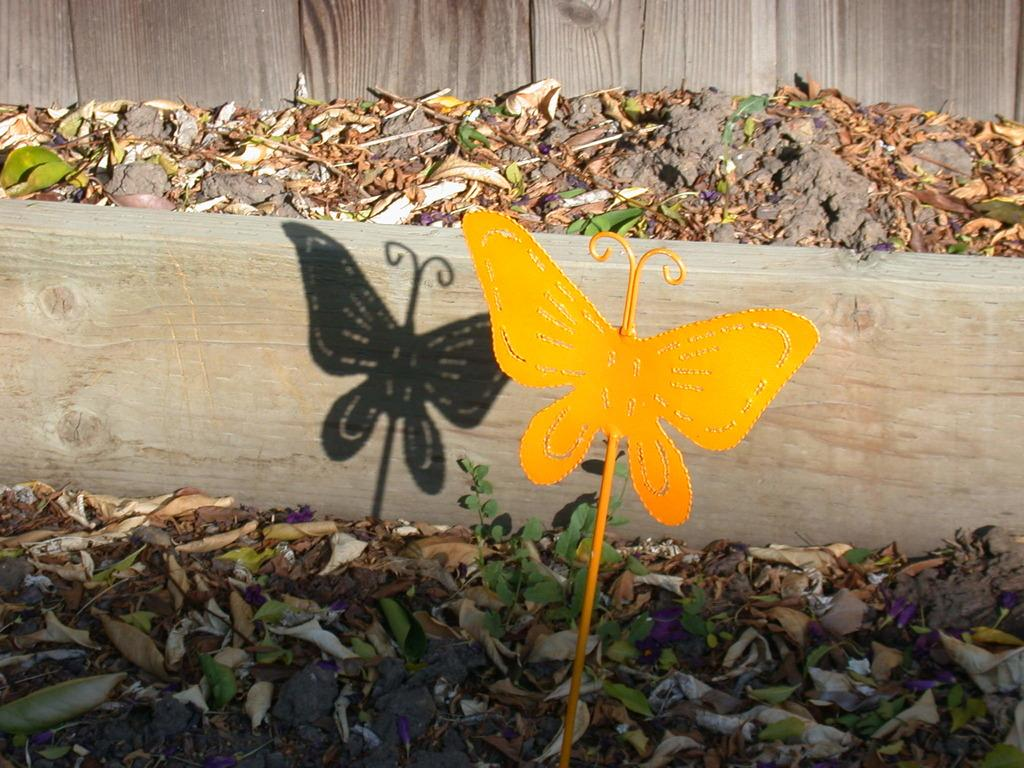What is the shape and color of the object in the image? The object in the image is in the shape of a butterfly and is yellow. What type of natural material can be seen in the image? Dried leaves are visible in the image. What type of material is the wooden object made of? The wooden object in the image is made of wood. Where is the police station located in the image? There is no police station present in the image. What type of food is being served in the lunchroom in the image? There is no lunchroom present in the image. 